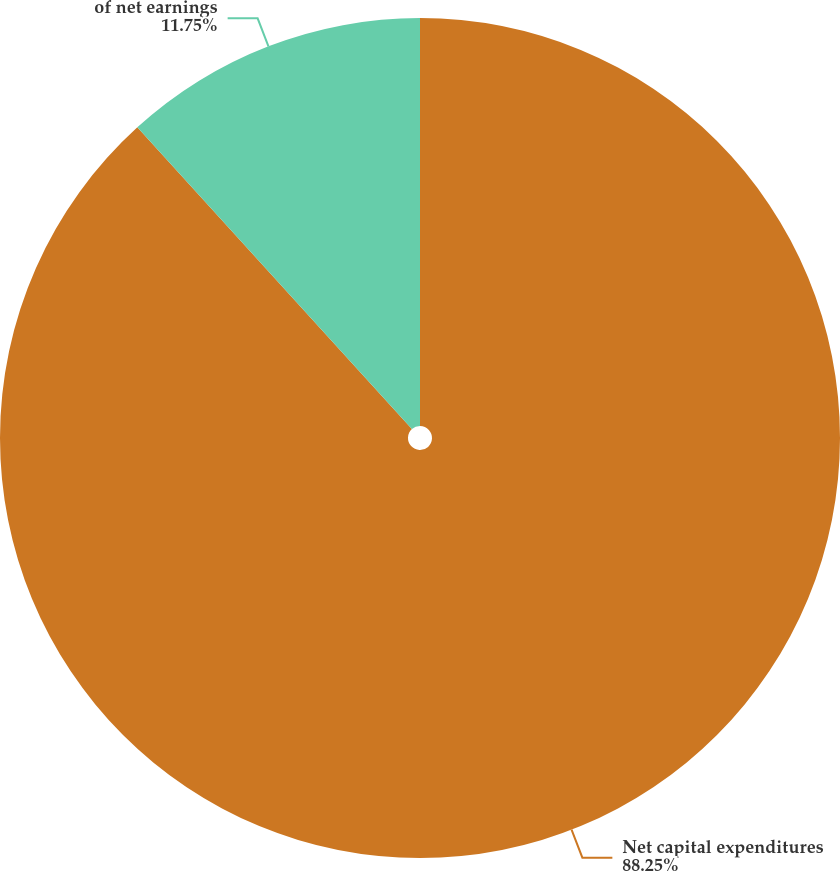Convert chart. <chart><loc_0><loc_0><loc_500><loc_500><pie_chart><fcel>Net capital expenditures<fcel>of net earnings<nl><fcel>88.25%<fcel>11.75%<nl></chart> 